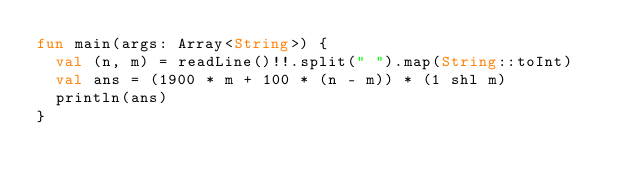Convert code to text. <code><loc_0><loc_0><loc_500><loc_500><_Kotlin_>fun main(args: Array<String>) {
  val (n, m) = readLine()!!.split(" ").map(String::toInt)
  val ans = (1900 * m + 100 * (n - m)) * (1 shl m)
  println(ans)
}
</code> 